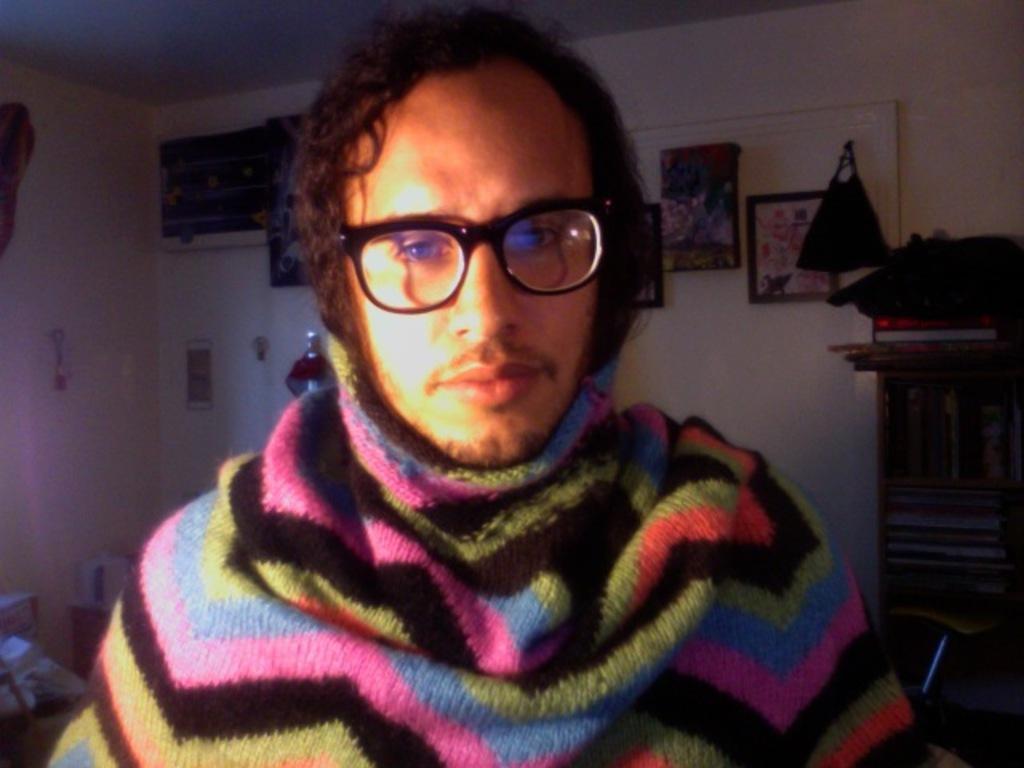In one or two sentences, can you explain what this image depicts? In this picture we can see a person wore a spectacle and in the background we can see frames, posters, bag and these all are on the wall, books in a rack and some objects. 